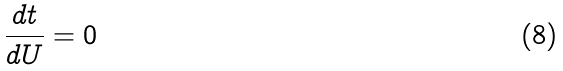<formula> <loc_0><loc_0><loc_500><loc_500>\frac { d t } { d U } = 0</formula> 